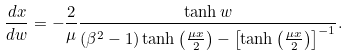Convert formula to latex. <formula><loc_0><loc_0><loc_500><loc_500>\frac { d x } { d w } = - \frac { 2 } { \mu } \frac { \tanh { w } } { ( \beta ^ { 2 } - 1 ) \tanh { \left ( \frac { \mu x } { 2 } \right ) } - \left [ \tanh { \left ( \frac { \mu x } { 2 } \right ) } \right ] ^ { - 1 } } .</formula> 